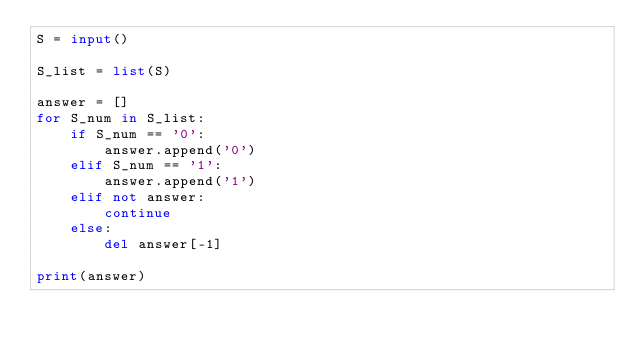Convert code to text. <code><loc_0><loc_0><loc_500><loc_500><_Python_>S = input()

S_list = list(S)

answer = []
for S_num in S_list:
    if S_num == '0':
        answer.append('0')
    elif S_num == '1':
        answer.append('1')
    elif not answer:
        continue
    else:
        del answer[-1]

print(answer)</code> 